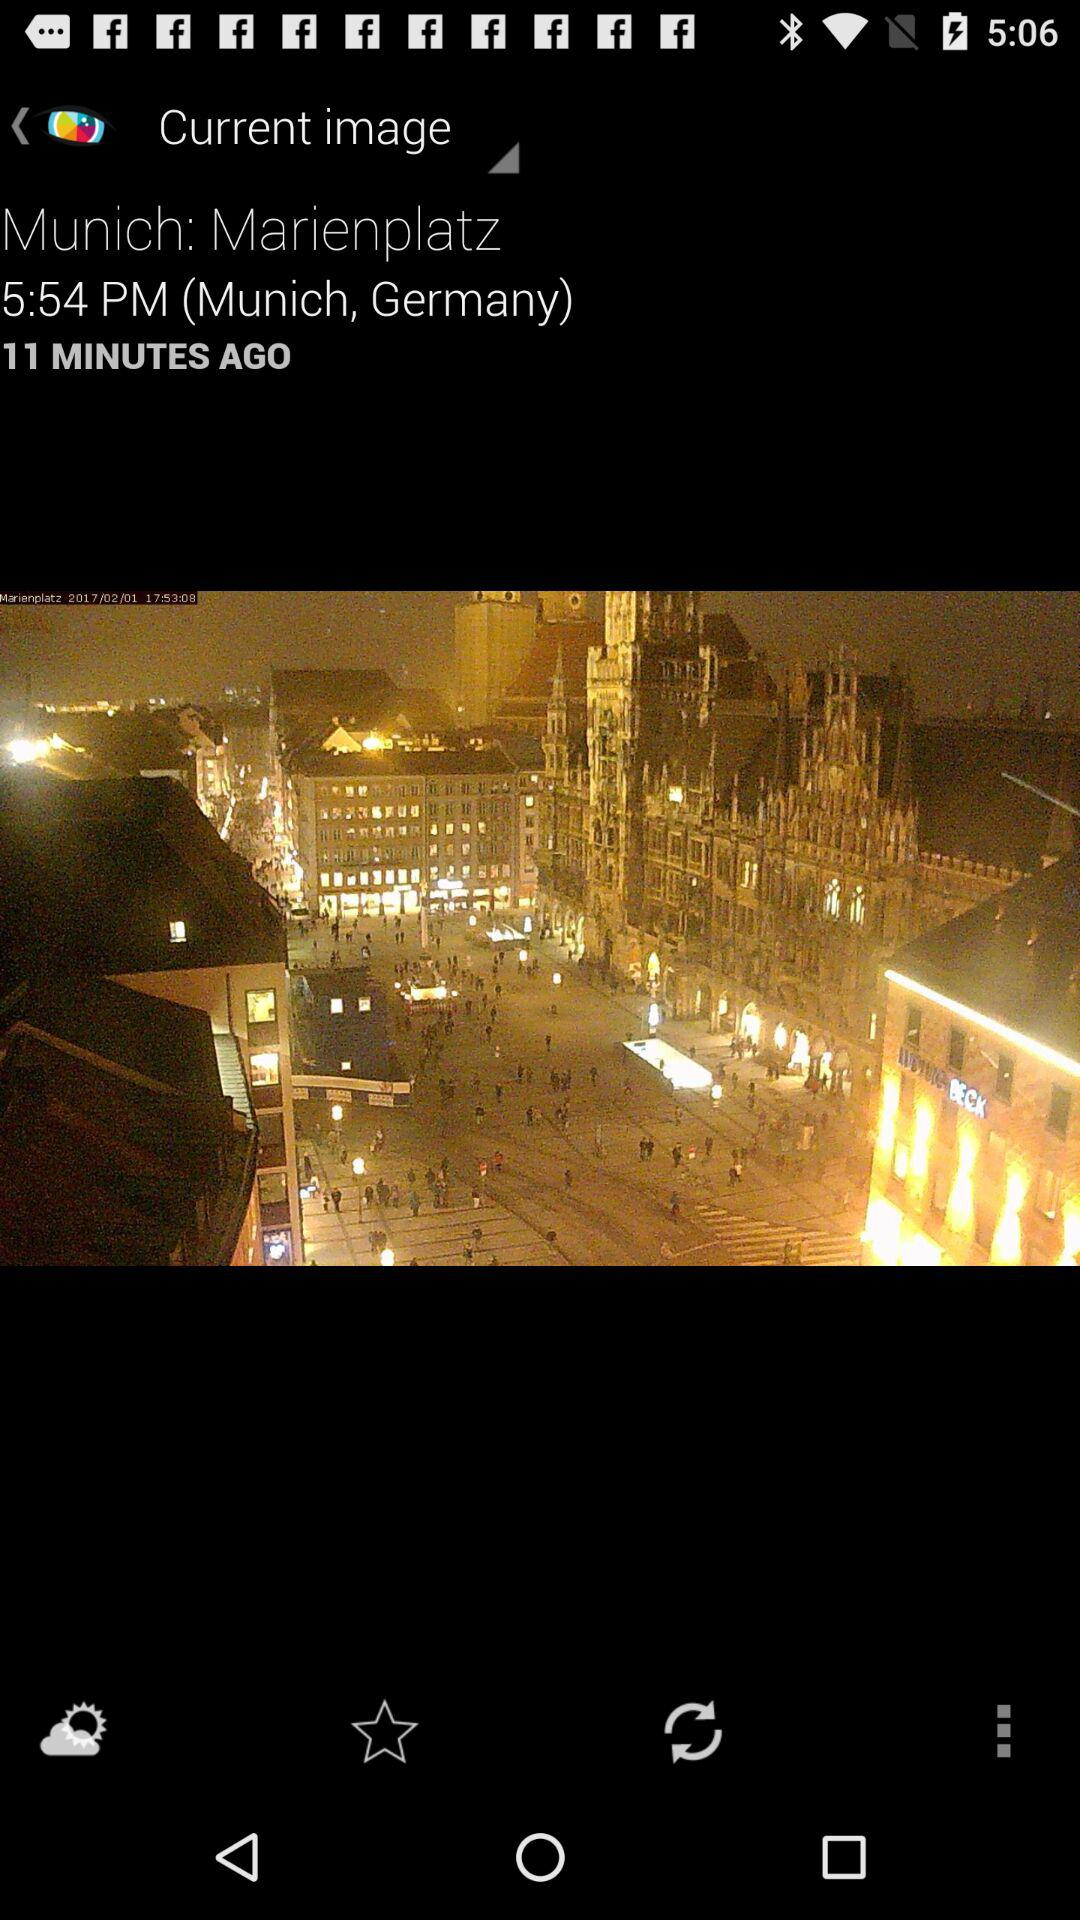What is the name of the place? The name of the place is Marienplatz in Munich, Germany. 